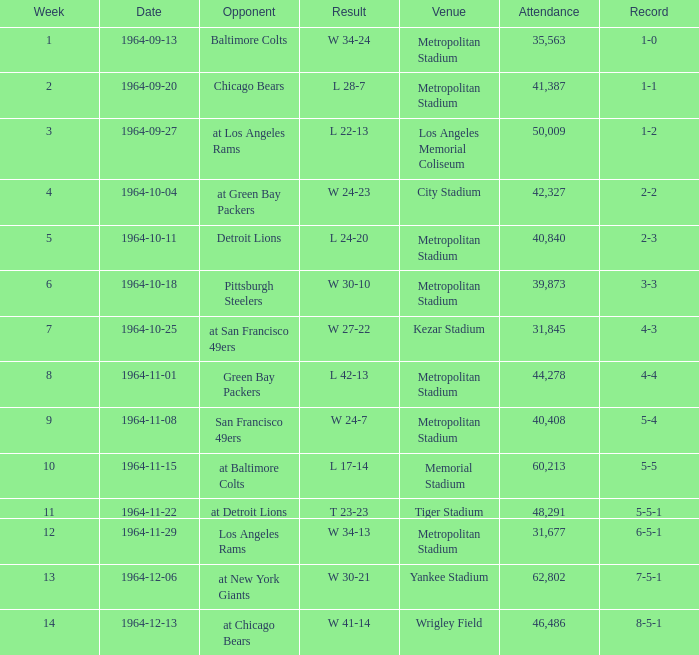What is the result when the record was 1-0 and it was earlier than week 4? W 34-24. 